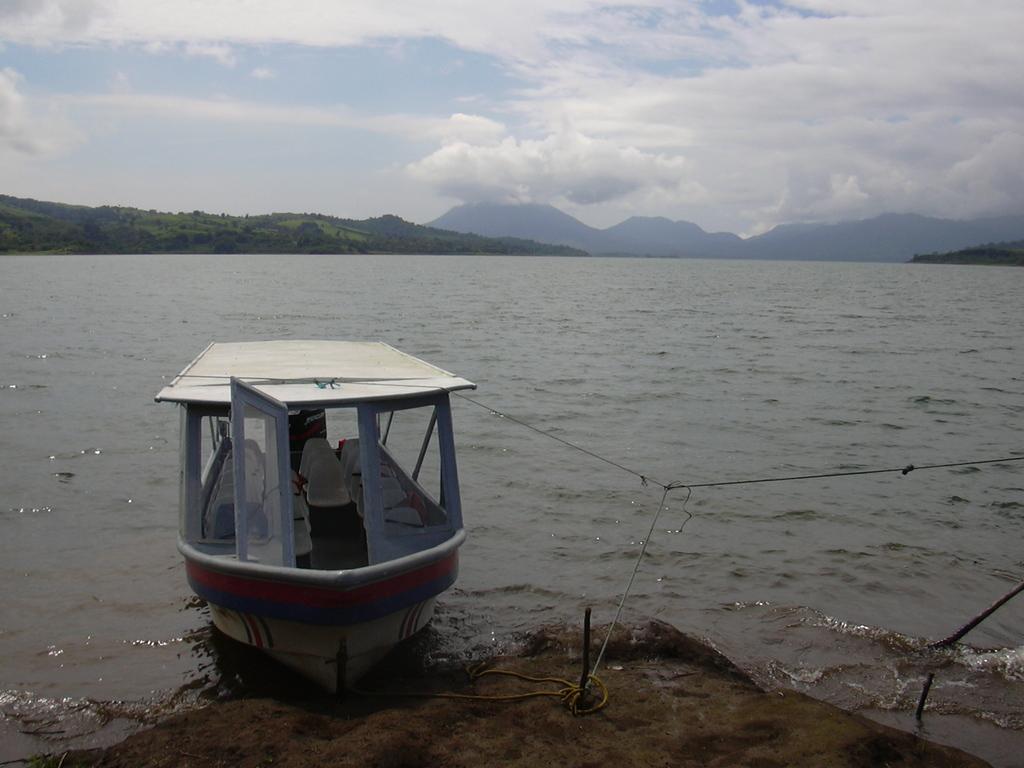How would you summarize this image in a sentence or two? In this image we can see a boat on the bank of the river and there are some mountains in the background. We can see the sky with clouds at the top. 